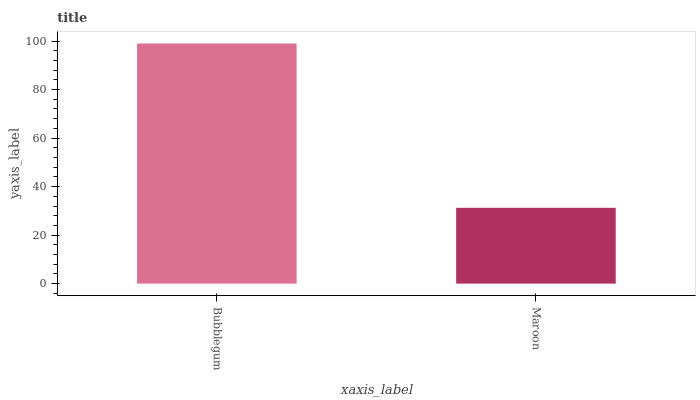Is Maroon the minimum?
Answer yes or no. Yes. Is Bubblegum the maximum?
Answer yes or no. Yes. Is Maroon the maximum?
Answer yes or no. No. Is Bubblegum greater than Maroon?
Answer yes or no. Yes. Is Maroon less than Bubblegum?
Answer yes or no. Yes. Is Maroon greater than Bubblegum?
Answer yes or no. No. Is Bubblegum less than Maroon?
Answer yes or no. No. Is Bubblegum the high median?
Answer yes or no. Yes. Is Maroon the low median?
Answer yes or no. Yes. Is Maroon the high median?
Answer yes or no. No. Is Bubblegum the low median?
Answer yes or no. No. 